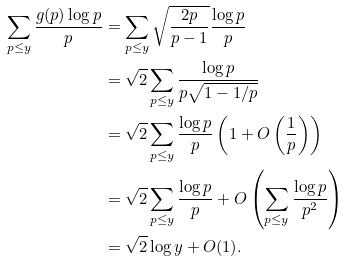Convert formula to latex. <formula><loc_0><loc_0><loc_500><loc_500>\sum _ { p \leq y } \frac { g ( p ) \log p } { p } & = \sum _ { p \leq y } \sqrt { \frac { 2 p } { p - 1 } } \frac { \log p } { p } \\ & = \sqrt { 2 } \sum _ { p \leq y } \frac { \log p } { p \sqrt { 1 - 1 / p } } \\ & = \sqrt { 2 } \sum _ { p \leq y } \frac { \log p } { p } \left ( 1 + O \left ( \frac { 1 } { p } \right ) \right ) \\ & = \sqrt { 2 } \sum _ { p \leq y } \frac { \log p } { p } + O \left ( \sum _ { p \leq y } \frac { \log p } { p ^ { 2 } } \right ) \\ & = \sqrt { 2 } \log y + O ( 1 ) .</formula> 